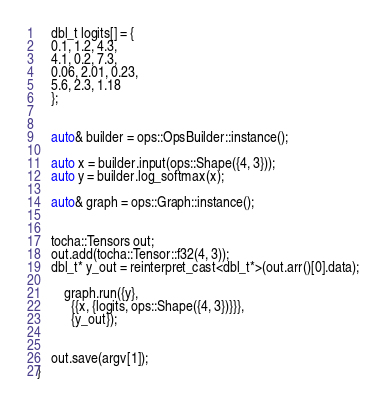Convert code to text. <code><loc_0><loc_0><loc_500><loc_500><_Cuda_>

    dbl_t logits[] = {
	0.1, 1.2, 4.3,
	4.1, 0.2, 7.3,
	0.06, 2.01, 0.23,
	5.6, 2.3, 1.18
    };


    auto& builder = ops::OpsBuilder::instance();
    
    auto x = builder.input(ops::Shape({4, 3}));
    auto y = builder.log_softmax(x);

    auto& graph = ops::Graph::instance();


    tocha::Tensors out;
    out.add(tocha::Tensor::f32(4, 3));
    dbl_t* y_out = reinterpret_cast<dbl_t*>(out.arr()[0].data);

        graph.run({y},
	      {{x, {logits, ops::Shape({4, 3})}}},
	      {y_out});
    
    
    out.save(argv[1]);
}
</code> 